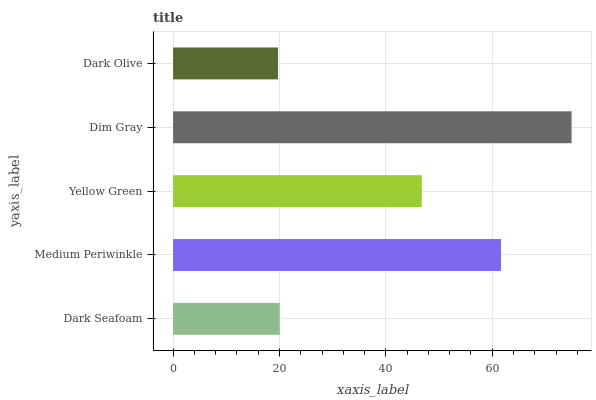Is Dark Olive the minimum?
Answer yes or no. Yes. Is Dim Gray the maximum?
Answer yes or no. Yes. Is Medium Periwinkle the minimum?
Answer yes or no. No. Is Medium Periwinkle the maximum?
Answer yes or no. No. Is Medium Periwinkle greater than Dark Seafoam?
Answer yes or no. Yes. Is Dark Seafoam less than Medium Periwinkle?
Answer yes or no. Yes. Is Dark Seafoam greater than Medium Periwinkle?
Answer yes or no. No. Is Medium Periwinkle less than Dark Seafoam?
Answer yes or no. No. Is Yellow Green the high median?
Answer yes or no. Yes. Is Yellow Green the low median?
Answer yes or no. Yes. Is Dark Seafoam the high median?
Answer yes or no. No. Is Medium Periwinkle the low median?
Answer yes or no. No. 